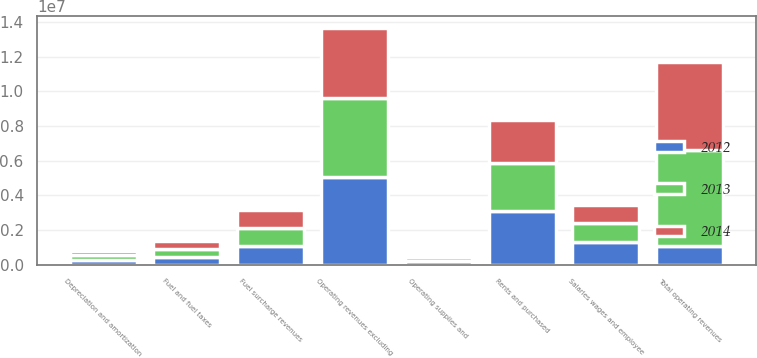Convert chart to OTSL. <chart><loc_0><loc_0><loc_500><loc_500><stacked_bar_chart><ecel><fcel>Operating revenues excluding<fcel>Fuel surcharge revenues<fcel>Total operating revenues<fcel>Rents and purchased<fcel>Salaries wages and employee<fcel>Fuel and fuel taxes<fcel>Depreciation and amortization<fcel>Operating supplies and<nl><fcel>2012<fcel>5.08283e+06<fcel>1.08261e+06<fcel>1.05733e+06<fcel>3.08528e+06<fcel>1.2904e+06<fcel>453919<fcel>294496<fcel>218539<nl><fcel>2013<fcel>4.52724e+06<fcel>1.05733e+06<fcel>5.58457e+06<fcel>2.80557e+06<fcel>1.13821e+06<fcel>455926<fcel>253380<fcel>202700<nl><fcel>2014<fcel>4.05816e+06<fcel>996815<fcel>5.05498e+06<fcel>2.48564e+06<fcel>1.03753e+06<fcel>465874<fcel>229166<fcel>178610<nl></chart> 